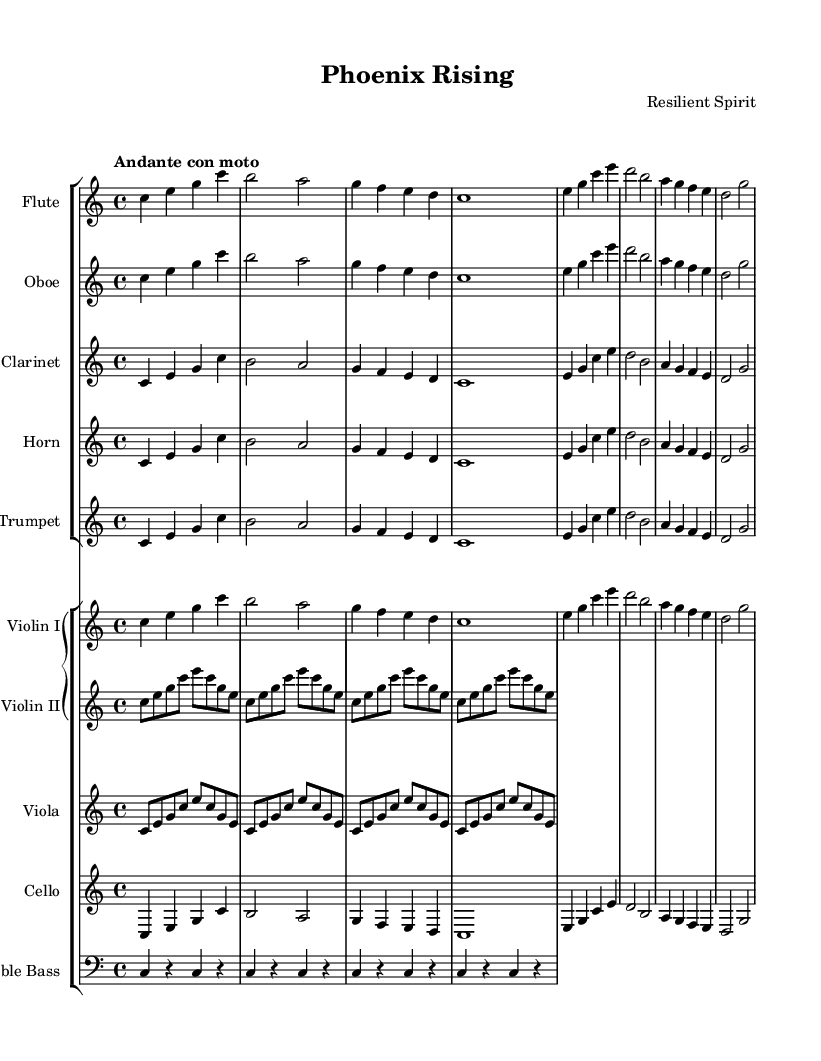What is the key signature of this music? The key signature is indicated at the beginning of the score, which shows no sharps or flats, confirming that it is in C major.
Answer: C major What is the time signature of this piece? The time signature is located at the beginning of the score and is shown as 4/4, indicating four beats per measure.
Answer: 4/4 What is the tempo indicated in this score? The tempo marking is found at the beginning, described as "Andante con moto," which suggests a moderate pace with some movement.
Answer: Andante con moto How many measures are in the first section of the symphony? By counting the measures in the flute part shown in the first section, there are a total of eight measures present before the next part repeats.
Answer: Eight Which instruments are specifically designated to play the main melody in this symphony? The flute, oboe, clarinet, horn, and trumpet all share similar melodic lines consistent with the symphonic style of writing, indicating they play the main melody.
Answer: Flute, Oboe, Clarinet, Horn, Trumpet What is the dynamic range indicated in the score for the strings? Although the score does not explicitly state dynamics consistently, we can infer from the notation style that the strings likely perform at a softer dynamic for the initial section.
Answer: Soft What is the main thematic development of this composition? The composition centers around a rising motif that symbolizes triumph and resilience, illustrated by the use of repeated notes and ascending intervals throughout the various instrumental parts.
Answer: Triumph over adversity 